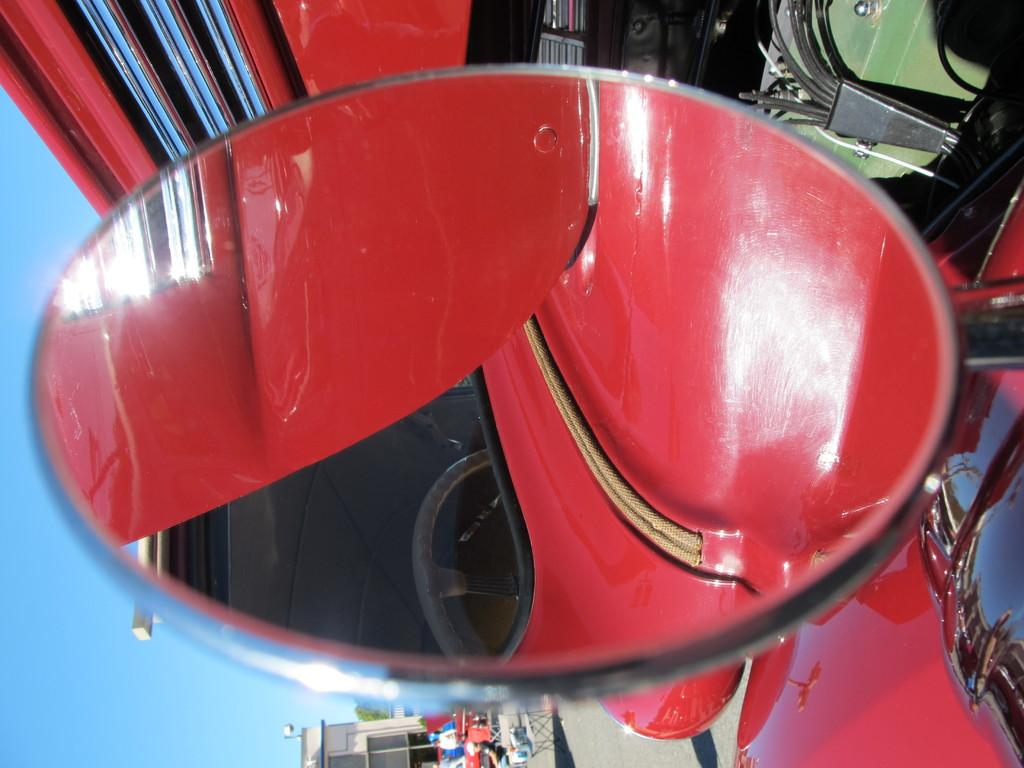What object is in the image that can be used for magnification? There is a magnifying glass in the image. What is the magnifying glass focused on? The magnifying glass is focused on a steering wheel. What color is the car that the steering wheel belongs to? The steering wheel belongs to a red car. Can you describe the car in the image? There is a red car in the image. What else can be seen in the background of the image? There are buildings and trees visible in the image. What type of vessel is being used to transport tomatoes in the image? There is no vessel or tomatoes present in the image. Can you describe the shape of the circle in the image? There is no circle present in the image. 